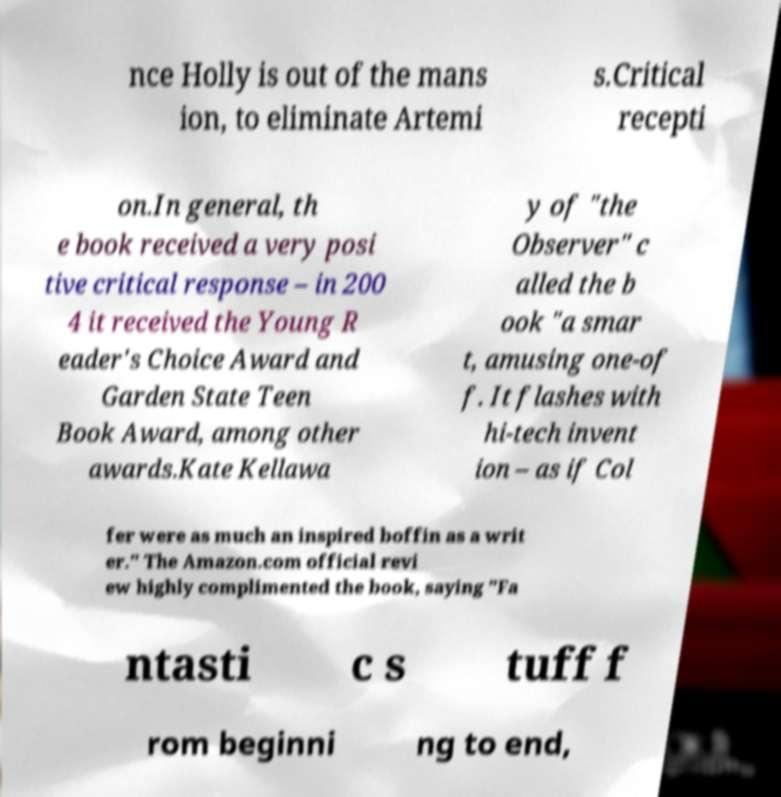Can you read and provide the text displayed in the image?This photo seems to have some interesting text. Can you extract and type it out for me? nce Holly is out of the mans ion, to eliminate Artemi s.Critical recepti on.In general, th e book received a very posi tive critical response – in 200 4 it received the Young R eader's Choice Award and Garden State Teen Book Award, among other awards.Kate Kellawa y of "the Observer" c alled the b ook "a smar t, amusing one-of f. It flashes with hi-tech invent ion – as if Col fer were as much an inspired boffin as a writ er." The Amazon.com official revi ew highly complimented the book, saying "Fa ntasti c s tuff f rom beginni ng to end, 